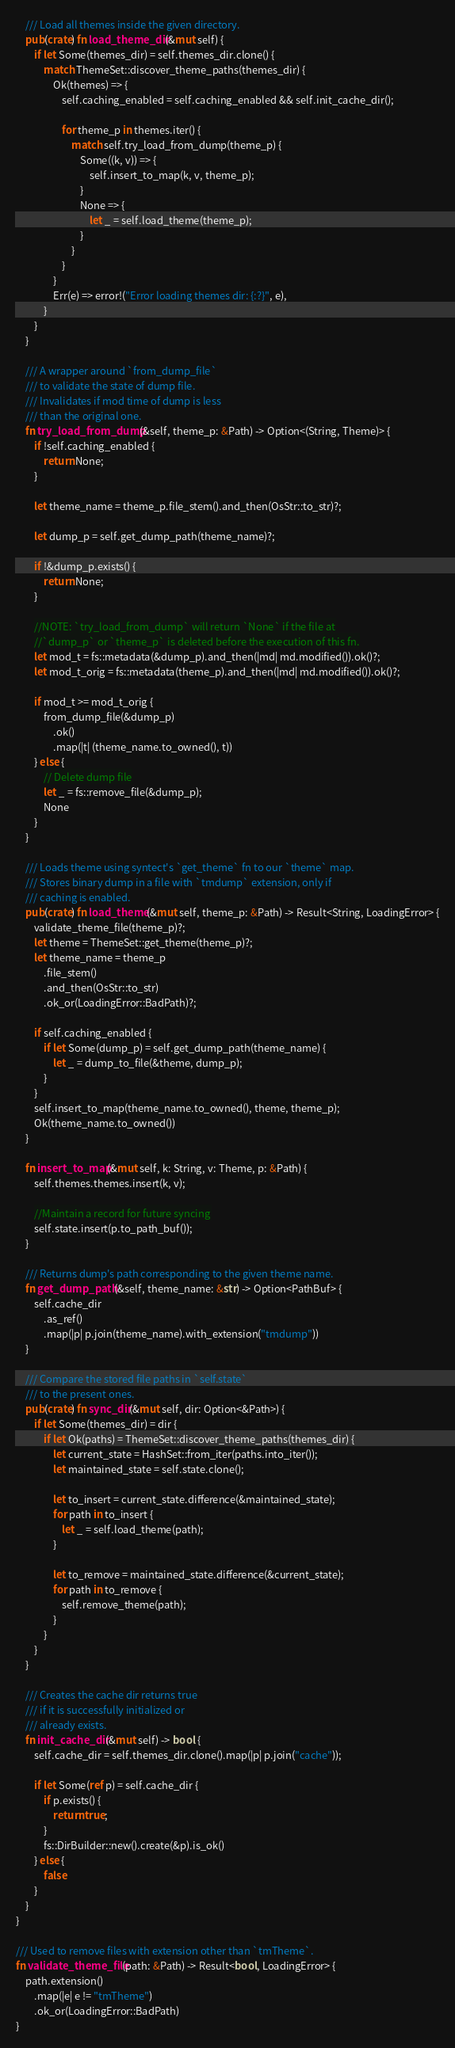<code> <loc_0><loc_0><loc_500><loc_500><_Rust_>    /// Load all themes inside the given directory.
    pub(crate) fn load_theme_dir(&mut self) {
        if let Some(themes_dir) = self.themes_dir.clone() {
            match ThemeSet::discover_theme_paths(themes_dir) {
                Ok(themes) => {
                    self.caching_enabled = self.caching_enabled && self.init_cache_dir();

                    for theme_p in themes.iter() {
                        match self.try_load_from_dump(theme_p) {
                            Some((k, v)) => {
                                self.insert_to_map(k, v, theme_p);
                            }
                            None => {
                                let _ = self.load_theme(theme_p);
                            }
                        }
                    }
                }
                Err(e) => error!("Error loading themes dir: {:?}", e),
            }
        }
    }

    /// A wrapper around `from_dump_file`
    /// to validate the state of dump file.
    /// Invalidates if mod time of dump is less
    /// than the original one.
    fn try_load_from_dump(&self, theme_p: &Path) -> Option<(String, Theme)> {
        if !self.caching_enabled {
            return None;
        }

        let theme_name = theme_p.file_stem().and_then(OsStr::to_str)?;

        let dump_p = self.get_dump_path(theme_name)?;

        if !&dump_p.exists() {
            return None;
        }

        //NOTE: `try_load_from_dump` will return `None` if the file at
        //`dump_p` or `theme_p` is deleted before the execution of this fn.
        let mod_t = fs::metadata(&dump_p).and_then(|md| md.modified()).ok()?;
        let mod_t_orig = fs::metadata(theme_p).and_then(|md| md.modified()).ok()?;

        if mod_t >= mod_t_orig {
            from_dump_file(&dump_p)
                .ok()
                .map(|t| (theme_name.to_owned(), t))
        } else {
            // Delete dump file
            let _ = fs::remove_file(&dump_p);
            None
        }
    }

    /// Loads theme using syntect's `get_theme` fn to our `theme` map.
    /// Stores binary dump in a file with `tmdump` extension, only if
    /// caching is enabled.
    pub(crate) fn load_theme(&mut self, theme_p: &Path) -> Result<String, LoadingError> {
        validate_theme_file(theme_p)?;
        let theme = ThemeSet::get_theme(theme_p)?;
        let theme_name = theme_p
            .file_stem()
            .and_then(OsStr::to_str)
            .ok_or(LoadingError::BadPath)?;

        if self.caching_enabled {
            if let Some(dump_p) = self.get_dump_path(theme_name) {
                let _ = dump_to_file(&theme, dump_p);
            }
        }
        self.insert_to_map(theme_name.to_owned(), theme, theme_p);
        Ok(theme_name.to_owned())
    }

    fn insert_to_map(&mut self, k: String, v: Theme, p: &Path) {
        self.themes.themes.insert(k, v);

        //Maintain a record for future syncing
        self.state.insert(p.to_path_buf());
    }

    /// Returns dump's path corresponding to the given theme name.
    fn get_dump_path(&self, theme_name: &str) -> Option<PathBuf> {
        self.cache_dir
            .as_ref()
            .map(|p| p.join(theme_name).with_extension("tmdump"))
    }

    /// Compare the stored file paths in `self.state`
    /// to the present ones.
    pub(crate) fn sync_dir(&mut self, dir: Option<&Path>) {
        if let Some(themes_dir) = dir {
            if let Ok(paths) = ThemeSet::discover_theme_paths(themes_dir) {
                let current_state = HashSet::from_iter(paths.into_iter());
                let maintained_state = self.state.clone();

                let to_insert = current_state.difference(&maintained_state);
                for path in to_insert {
                    let _ = self.load_theme(path);
                }

                let to_remove = maintained_state.difference(&current_state);
                for path in to_remove {
                    self.remove_theme(path);
                }
            }
        }
    }

    /// Creates the cache dir returns true
    /// if it is successfully initialized or
    /// already exists.
    fn init_cache_dir(&mut self) -> bool {
        self.cache_dir = self.themes_dir.clone().map(|p| p.join("cache"));

        if let Some(ref p) = self.cache_dir {
            if p.exists() {
                return true;
            }
            fs::DirBuilder::new().create(&p).is_ok()
        } else {
            false
        }
    }
}

/// Used to remove files with extension other than `tmTheme`.
fn validate_theme_file(path: &Path) -> Result<bool, LoadingError> {
    path.extension()
        .map(|e| e != "tmTheme")
        .ok_or(LoadingError::BadPath)
}
</code> 